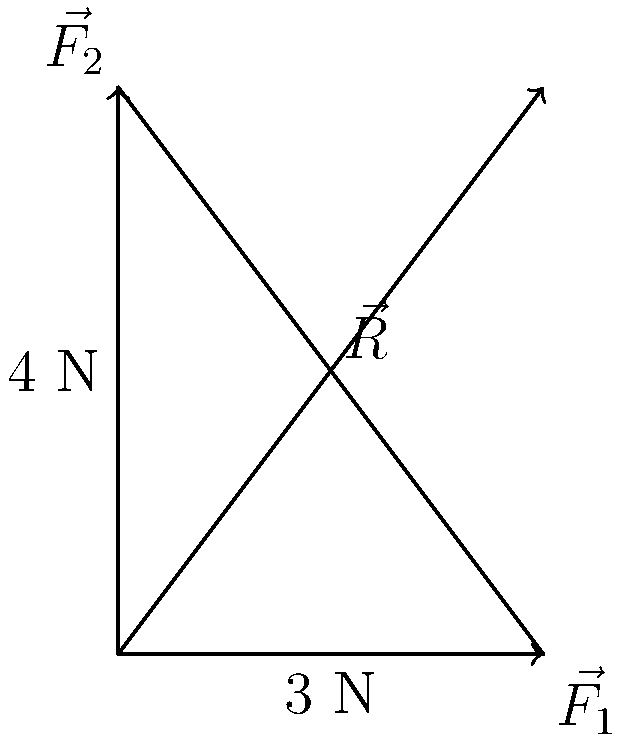In the force diagram above, two forces $\vec{F_1}$ and $\vec{F_2}$ are acting on a point. $\vec{F_1}$ has a magnitude of 3 N and $\vec{F_2}$ has a magnitude of 4 N. They are perpendicular to each other. Calculate the magnitude of the resultant force $\vec{R}$, ensuring your answer is expressed to two decimal places. To find the magnitude of the resultant force $\vec{R}$, we can use the Pythagorean theorem, as the two forces are perpendicular to each other.

Let's proceed step-by-step:

1) The magnitude of $\vec{F_1}$ is 3 N and the magnitude of $\vec{F_2}$ is 4 N.

2) According to the Pythagorean theorem, in a right-angled triangle:
   $$c^2 = a^2 + b^2$$
   where $c$ is the hypotenuse and $a$ and $b$ are the other two sides.

3) In our case, $\vec{R}$ is the hypotenuse, and $\vec{F_1}$ and $\vec{F_2}$ form the other two sides of the right-angled triangle. So:
   $$|\vec{R}|^2 = |\vec{F_1}|^2 + |\vec{F_2}|^2$$

4) Substituting the values:
   $$|\vec{R}|^2 = 3^2 + 4^2 = 9 + 16 = 25$$

5) Taking the square root of both sides:
   $$|\vec{R}| = \sqrt{25} = 5$$

6) The question asks for the answer to two decimal places, so our final answer is 5.00 N.
Answer: 5.00 N 